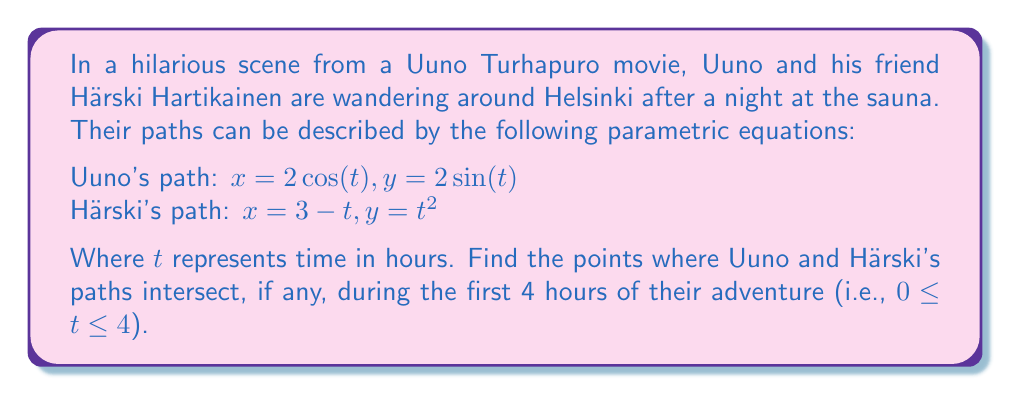Can you answer this question? To find the points of intersection, we need to equate the x and y coordinates of both paths:

1) Equate x-coordinates:
   $2\cos(t) = 3 - t$

2) Equate y-coordinates:
   $2\sin(t) = t^2$

3) From the first equation:
   $t = 3 - 2\cos(t)$

4) Substitute this into the second equation:
   $2\sin(t) = (3 - 2\cos(t))^2$
   $2\sin(t) = 9 - 12\cos(t) + 4\cos^2(t)$

5) Use the trigonometric identity $\sin^2(t) + \cos^2(t) = 1$:
   $2\sin(t) = 9 - 12\cos(t) + 4(1-\sin^2(t))$
   $2\sin(t) = 13 - 12\cos(t) - 4\sin^2(t)$
   $4\sin^2(t) + 2\sin(t) + 12\cos(t) - 13 = 0$

6) This is a complex equation to solve analytically. We can use numerical methods or graphing to find the solutions within the given range.

7) Using a graphing calculator or computer algebra system, we find two solutions within $0 \leq t \leq 4$:
   $t \approx 0.5236$ and $t \approx 2.6180$

8) For $t \approx 0.5236$:
   Uuno: $x \approx 1.7321, y \approx 1.0000$
   Härski: $x \approx 2.4764, y \approx 0.2741$

9) For $t \approx 2.6180$:
   Uuno: $x \approx -1.7321, y \approx 1.0000$
   Härski: $x \approx 0.3820, y \approx 6.8541$

10) The second solution is outside the range of Uuno's path, so we discard it.
Answer: Uuno and Härski's paths intersect at approximately $(1.7321, 1.0000)$ when $t \approx 0.5236$ hours (about 31 minutes) into their adventure. 